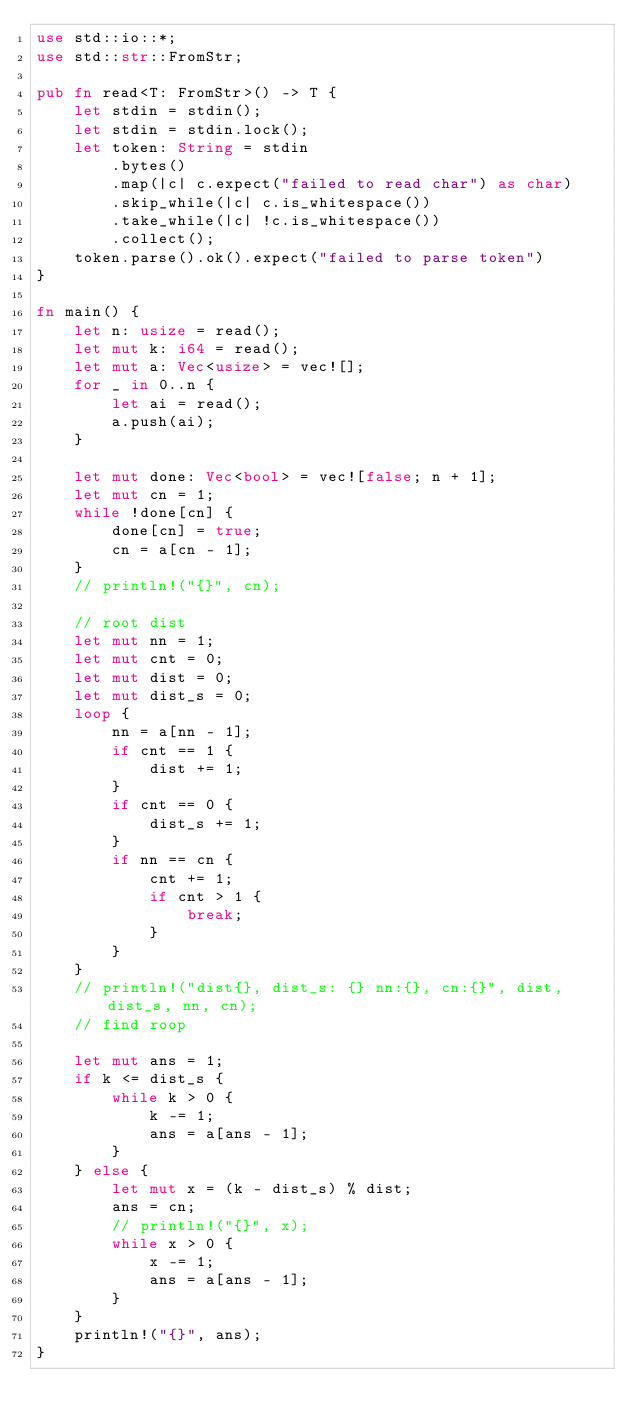<code> <loc_0><loc_0><loc_500><loc_500><_Rust_>use std::io::*;
use std::str::FromStr;

pub fn read<T: FromStr>() -> T {
    let stdin = stdin();
    let stdin = stdin.lock();
    let token: String = stdin
        .bytes()
        .map(|c| c.expect("failed to read char") as char)
        .skip_while(|c| c.is_whitespace())
        .take_while(|c| !c.is_whitespace())
        .collect();
    token.parse().ok().expect("failed to parse token")
}

fn main() {
    let n: usize = read();
    let mut k: i64 = read();
    let mut a: Vec<usize> = vec![];
    for _ in 0..n {
        let ai = read();
        a.push(ai);
    }

    let mut done: Vec<bool> = vec![false; n + 1];
    let mut cn = 1;
    while !done[cn] {
        done[cn] = true;
        cn = a[cn - 1];
    }
    // println!("{}", cn);

    // root dist
    let mut nn = 1;
    let mut cnt = 0;
    let mut dist = 0;
    let mut dist_s = 0;
    loop {
        nn = a[nn - 1];
        if cnt == 1 {
            dist += 1;
        }
        if cnt == 0 {
            dist_s += 1;
        }
        if nn == cn {
            cnt += 1;
            if cnt > 1 {
                break;
            }
        }
    }
    // println!("dist{}, dist_s: {} nn:{}, cn:{}", dist, dist_s, nn, cn);
    // find roop

    let mut ans = 1;
    if k <= dist_s {
        while k > 0 {
            k -= 1;
            ans = a[ans - 1];
        }
    } else {
        let mut x = (k - dist_s) % dist;
        ans = cn;
        // println!("{}", x);
        while x > 0 {
            x -= 1;
            ans = a[ans - 1];
        }
    }
    println!("{}", ans);
}
</code> 